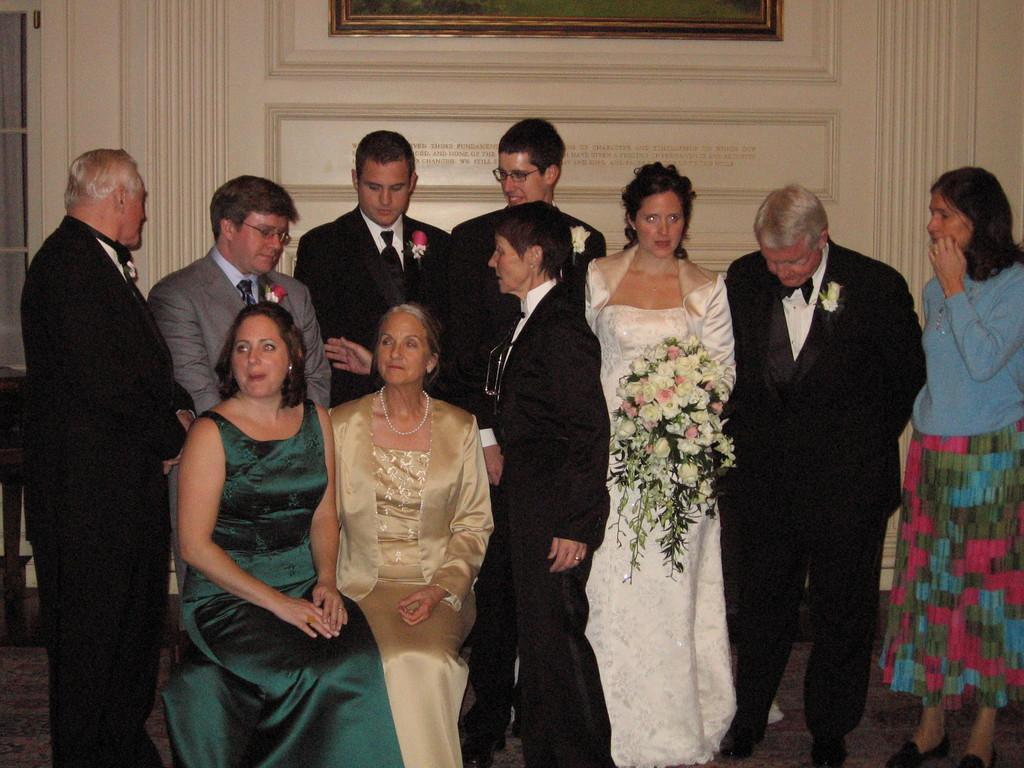Could you give a brief overview of what you see in this image? In the center of the image we can see many person sitting and standing on the floor. In the background we can see door, photo frame and wall. 